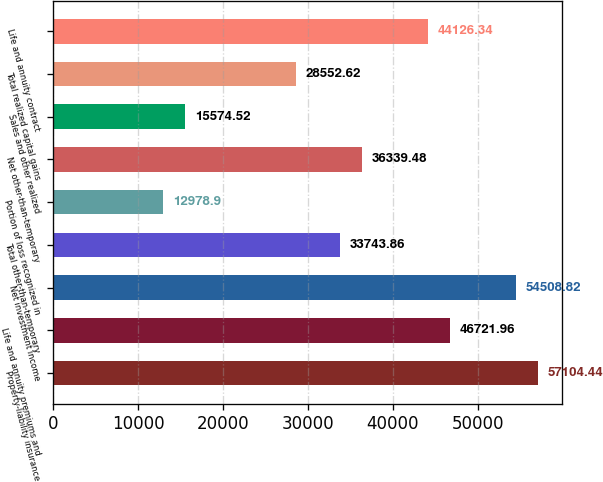Convert chart to OTSL. <chart><loc_0><loc_0><loc_500><loc_500><bar_chart><fcel>Property-liability insurance<fcel>Life and annuity premiums and<fcel>Net investment income<fcel>Total other-than-temporary<fcel>Portion of loss recognized in<fcel>Net other-than-temporary<fcel>Sales and other realized<fcel>Total realized capital gains<fcel>Life and annuity contract<nl><fcel>57104.4<fcel>46722<fcel>54508.8<fcel>33743.9<fcel>12978.9<fcel>36339.5<fcel>15574.5<fcel>28552.6<fcel>44126.3<nl></chart> 